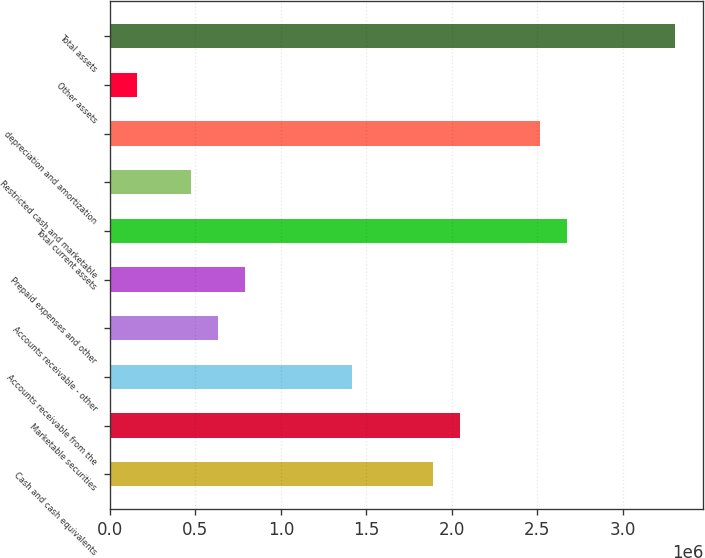Convert chart to OTSL. <chart><loc_0><loc_0><loc_500><loc_500><bar_chart><fcel>Cash and cash equivalents<fcel>Marketable securities<fcel>Accounts receivable from the<fcel>Accounts receivable - other<fcel>Prepaid expenses and other<fcel>Total current assets<fcel>Restricted cash and marketable<fcel>depreciation and amortization<fcel>Other assets<fcel>Total assets<nl><fcel>1.89044e+06<fcel>2.04777e+06<fcel>1.41845e+06<fcel>631807<fcel>789136<fcel>2.67708e+06<fcel>474478<fcel>2.51975e+06<fcel>159820<fcel>3.3064e+06<nl></chart> 